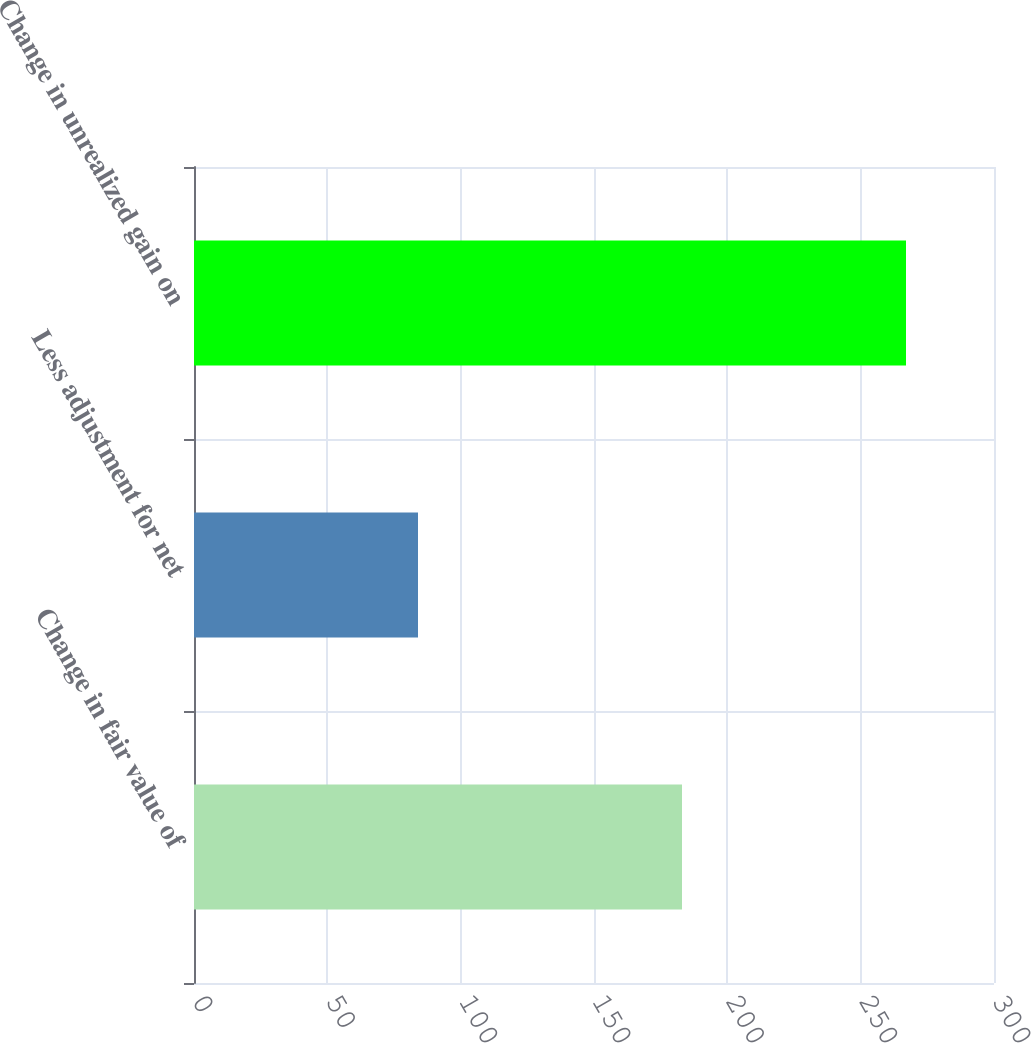<chart> <loc_0><loc_0><loc_500><loc_500><bar_chart><fcel>Change in fair value of<fcel>Less adjustment for net<fcel>Change in unrealized gain on<nl><fcel>183<fcel>84<fcel>267<nl></chart> 